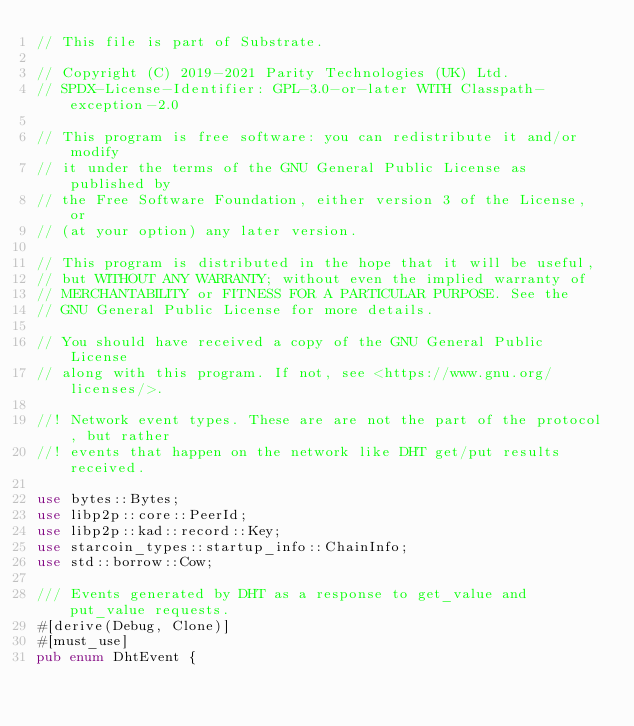<code> <loc_0><loc_0><loc_500><loc_500><_Rust_>// This file is part of Substrate.

// Copyright (C) 2019-2021 Parity Technologies (UK) Ltd.
// SPDX-License-Identifier: GPL-3.0-or-later WITH Classpath-exception-2.0

// This program is free software: you can redistribute it and/or modify
// it under the terms of the GNU General Public License as published by
// the Free Software Foundation, either version 3 of the License, or
// (at your option) any later version.

// This program is distributed in the hope that it will be useful,
// but WITHOUT ANY WARRANTY; without even the implied warranty of
// MERCHANTABILITY or FITNESS FOR A PARTICULAR PURPOSE. See the
// GNU General Public License for more details.

// You should have received a copy of the GNU General Public License
// along with this program. If not, see <https://www.gnu.org/licenses/>.

//! Network event types. These are are not the part of the protocol, but rather
//! events that happen on the network like DHT get/put results received.

use bytes::Bytes;
use libp2p::core::PeerId;
use libp2p::kad::record::Key;
use starcoin_types::startup_info::ChainInfo;
use std::borrow::Cow;

/// Events generated by DHT as a response to get_value and put_value requests.
#[derive(Debug, Clone)]
#[must_use]
pub enum DhtEvent {</code> 